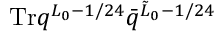Convert formula to latex. <formula><loc_0><loc_0><loc_500><loc_500>T r q ^ { L _ { 0 } - 1 / 2 4 } \bar { q } ^ { \tilde { L } _ { 0 } - 1 / 2 4 }</formula> 